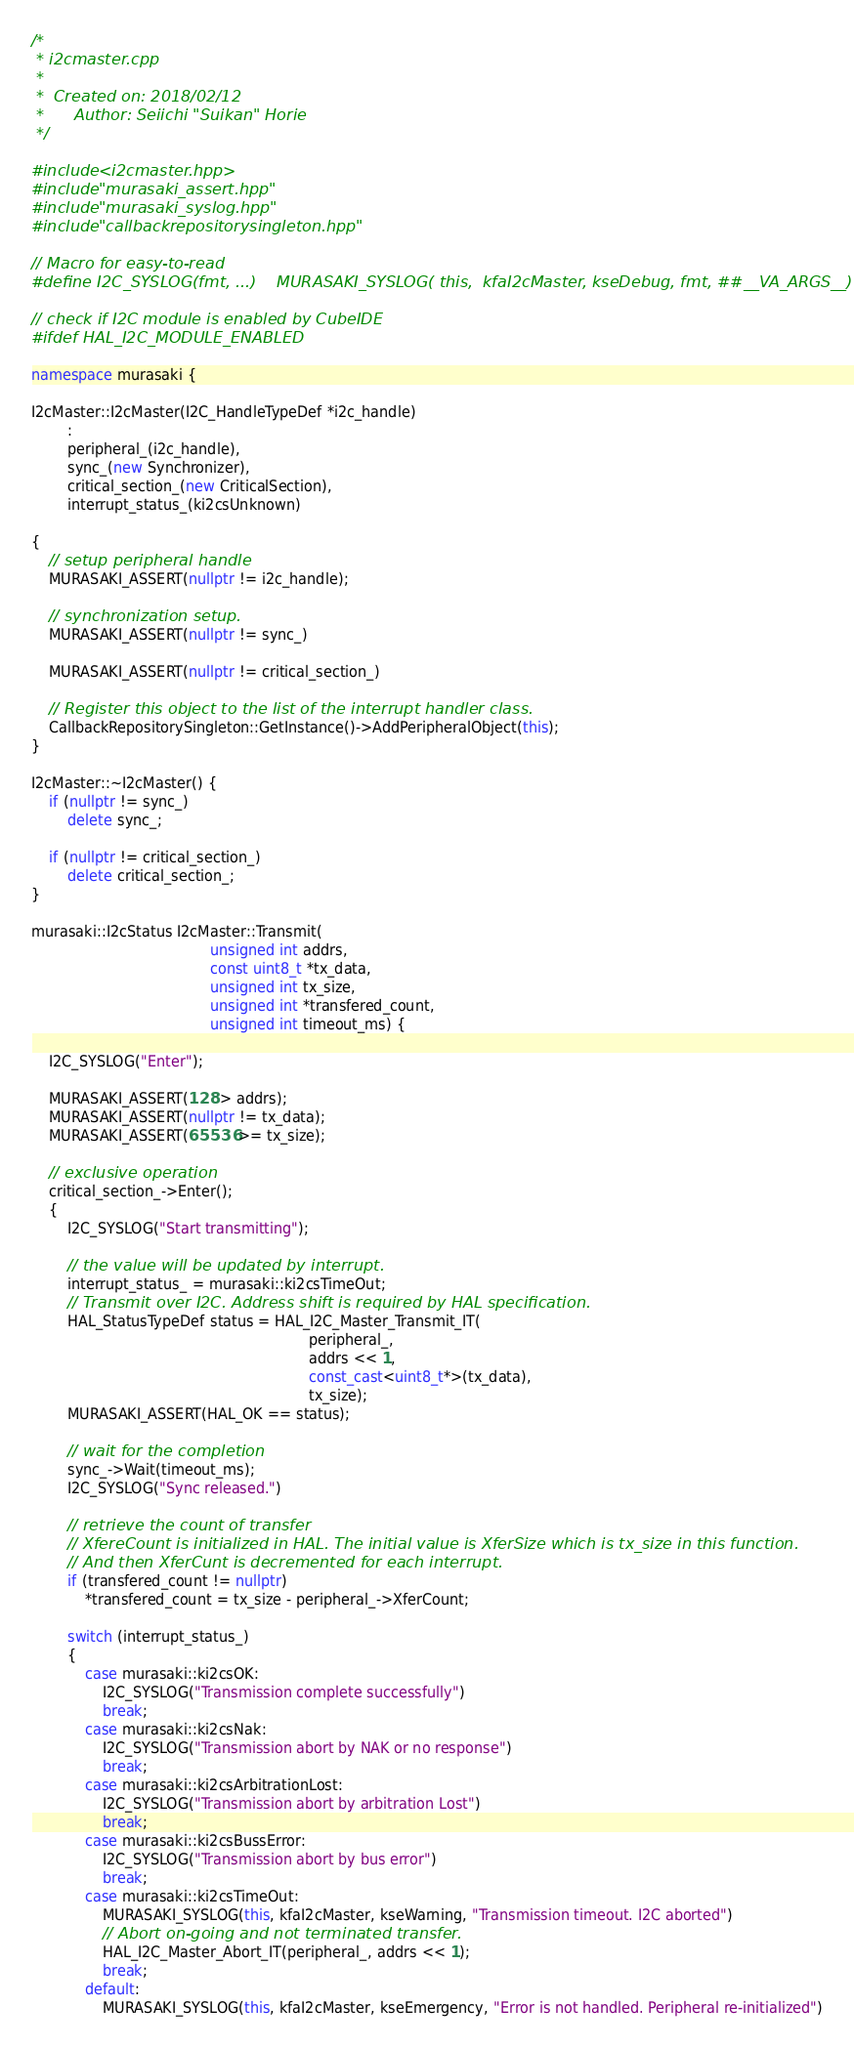<code> <loc_0><loc_0><loc_500><loc_500><_C++_>/*
 * i2cmaster.cpp
 *
 *  Created on: 2018/02/12
 *      Author: Seiichi "Suikan" Horie
 */

#include <i2cmaster.hpp>
#include "murasaki_assert.hpp"
#include "murasaki_syslog.hpp"
#include "callbackrepositorysingleton.hpp"

// Macro for easy-to-read
#define I2C_SYSLOG(fmt, ...)    MURASAKI_SYSLOG( this,  kfaI2cMaster, kseDebug, fmt, ##__VA_ARGS__)

// check if I2C module is enabled by CubeIDE
#ifdef HAL_I2C_MODULE_ENABLED

namespace murasaki {

I2cMaster::I2cMaster(I2C_HandleTypeDef *i2c_handle)
        :
        peripheral_(i2c_handle),
        sync_(new Synchronizer),
        critical_section_(new CriticalSection),
        interrupt_status_(ki2csUnknown)

{
    // setup peripheral handle
    MURASAKI_ASSERT(nullptr != i2c_handle);

    // synchronization setup.
    MURASAKI_ASSERT(nullptr != sync_)

    MURASAKI_ASSERT(nullptr != critical_section_)

    // Register this object to the list of the interrupt handler class.
    CallbackRepositorySingleton::GetInstance()->AddPeripheralObject(this);
}

I2cMaster::~I2cMaster() {
    if (nullptr != sync_)
        delete sync_;

    if (nullptr != critical_section_)
        delete critical_section_;
}

murasaki::I2cStatus I2cMaster::Transmit(
                                        unsigned int addrs,
                                        const uint8_t *tx_data,
                                        unsigned int tx_size,
                                        unsigned int *transfered_count,
                                        unsigned int timeout_ms) {

    I2C_SYSLOG("Enter");

    MURASAKI_ASSERT(128 > addrs);
    MURASAKI_ASSERT(nullptr != tx_data);
    MURASAKI_ASSERT(65536 >= tx_size);

    // exclusive operation
    critical_section_->Enter();
    {
        I2C_SYSLOG("Start transmitting");

        // the value will be updated by interrupt.
        interrupt_status_ = murasaki::ki2csTimeOut;
        // Transmit over I2C. Address shift is required by HAL specification.
        HAL_StatusTypeDef status = HAL_I2C_Master_Transmit_IT(
                                                              peripheral_,
                                                              addrs << 1,
                                                              const_cast<uint8_t*>(tx_data),
                                                              tx_size);
        MURASAKI_ASSERT(HAL_OK == status);

        // wait for the completion
        sync_->Wait(timeout_ms);
        I2C_SYSLOG("Sync released.")

        // retrieve the count of transfer
        // XfereCount is initialized in HAL. The initial value is XferSize which is tx_size in this function.
        // And then XferCunt is decremented for each interrupt.
        if (transfered_count != nullptr)
            *transfered_count = tx_size - peripheral_->XferCount;

        switch (interrupt_status_)
        {
            case murasaki::ki2csOK:
                I2C_SYSLOG("Transmission complete successfully")
                break;
            case murasaki::ki2csNak:
                I2C_SYSLOG("Transmission abort by NAK or no response")
                break;
            case murasaki::ki2csArbitrationLost:
                I2C_SYSLOG("Transmission abort by arbitration Lost")
                break;
            case murasaki::ki2csBussError:
                I2C_SYSLOG("Transmission abort by bus error")
                break;
            case murasaki::ki2csTimeOut:
                MURASAKI_SYSLOG(this, kfaI2cMaster, kseWarning, "Transmission timeout. I2C aborted")
                // Abort on-going and not terminated transfer.
                HAL_I2C_Master_Abort_IT(peripheral_, addrs << 1);
                break;
            default:
                MURASAKI_SYSLOG(this, kfaI2cMaster, kseEmergency, "Error is not handled. Peripheral re-initialized")</code> 